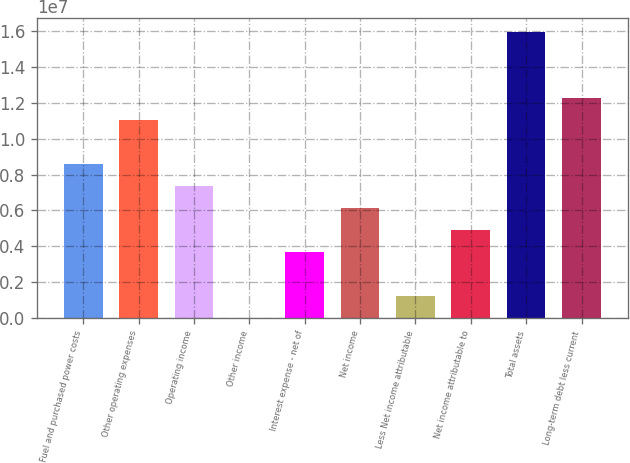Convert chart. <chart><loc_0><loc_0><loc_500><loc_500><bar_chart><fcel>Fuel and purchased power costs<fcel>Other operating expenses<fcel>Operating income<fcel>Other income<fcel>Interest expense - net of<fcel>Net income<fcel>Less Net income attributable<fcel>Net income attributable to<fcel>Total assets<fcel>Long-term debt less current<nl><fcel>8.59636e+06<fcel>1.10467e+07<fcel>7.37118e+06<fcel>20138<fcel>3.69566e+06<fcel>6.14601e+06<fcel>1.24531e+06<fcel>4.92083e+06<fcel>1.59474e+07<fcel>1.22719e+07<nl></chart> 